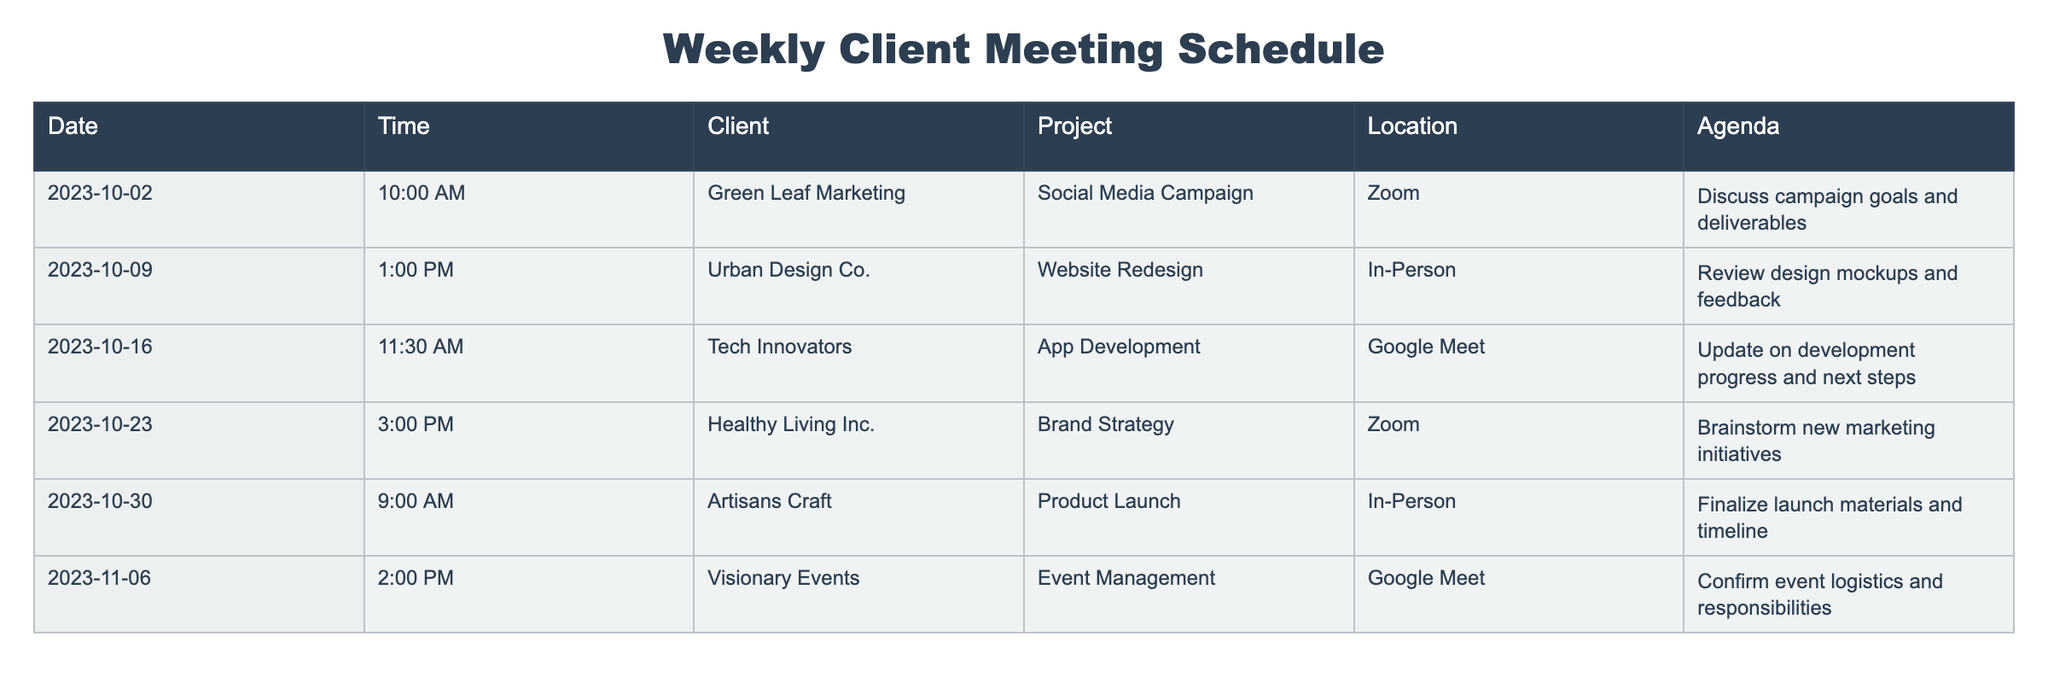What is the date of the meeting with Tech Innovators? According to the table, the meeting with Tech Innovators is scheduled for October 16, 2023.
Answer: October 16, 2023 How many meetings are scheduled for the month of October? The table lists meetings on October 2, October 9, October 16, and October 23, and October 30, totaling 5 meetings.
Answer: 5 Which project has its meeting scheduled at 9:00 AM? The meeting scheduled at 9:00 AM is for the project "Product Launch" with Artisans Craft on October 30, 2023.
Answer: Product Launch Is there any meeting scheduled for November? Yes, there is a meeting scheduled for November 6, 2023, with Visionary Events.
Answer: Yes What is the average time of all meetings scheduled in the table? The meeting times are 10:00 AM, 1:00 PM, 11:30 AM, 3:00 PM, 9:00 AM, and 2:00 PM. To find the average: convert these times to minutes past midnight (600, 780, 690, 900, 540, 840), sum them up to get 3840 minutes, and divide by the number of meetings (6), which equals 640 minutes. Converting back gives us 10:40 AM as the average time.
Answer: 10:40 AM How many meetings are conducted via Zoom? There are 2 meetings that are conducted via Zoom: one on October 2 (Green Leaf Marketing) and another on October 23 (Healthy Living Inc.).
Answer: 2 